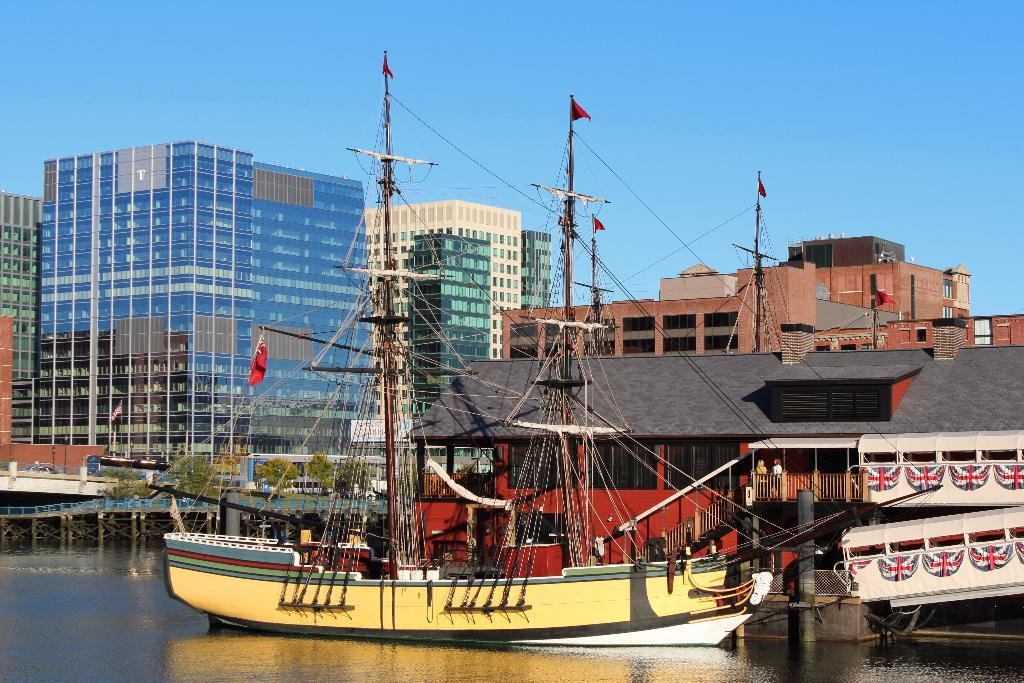What can be seen at the bottom of the image? There are boats, water, a bridge, and a house at the bottom of the image. What is present in the middle of the image? There are flags, cables, buildings, trees, a railing, and people in the middle of the image. What part of the image is visible in the sky? The sky is visible in the middle of the image. Can you tell me which person in the image is wearing a locket? There is no mention of a locket or any jewelry in the image. What type of disease is affecting the trees in the middle of the image? There is no indication of any disease affecting the trees in the image. 